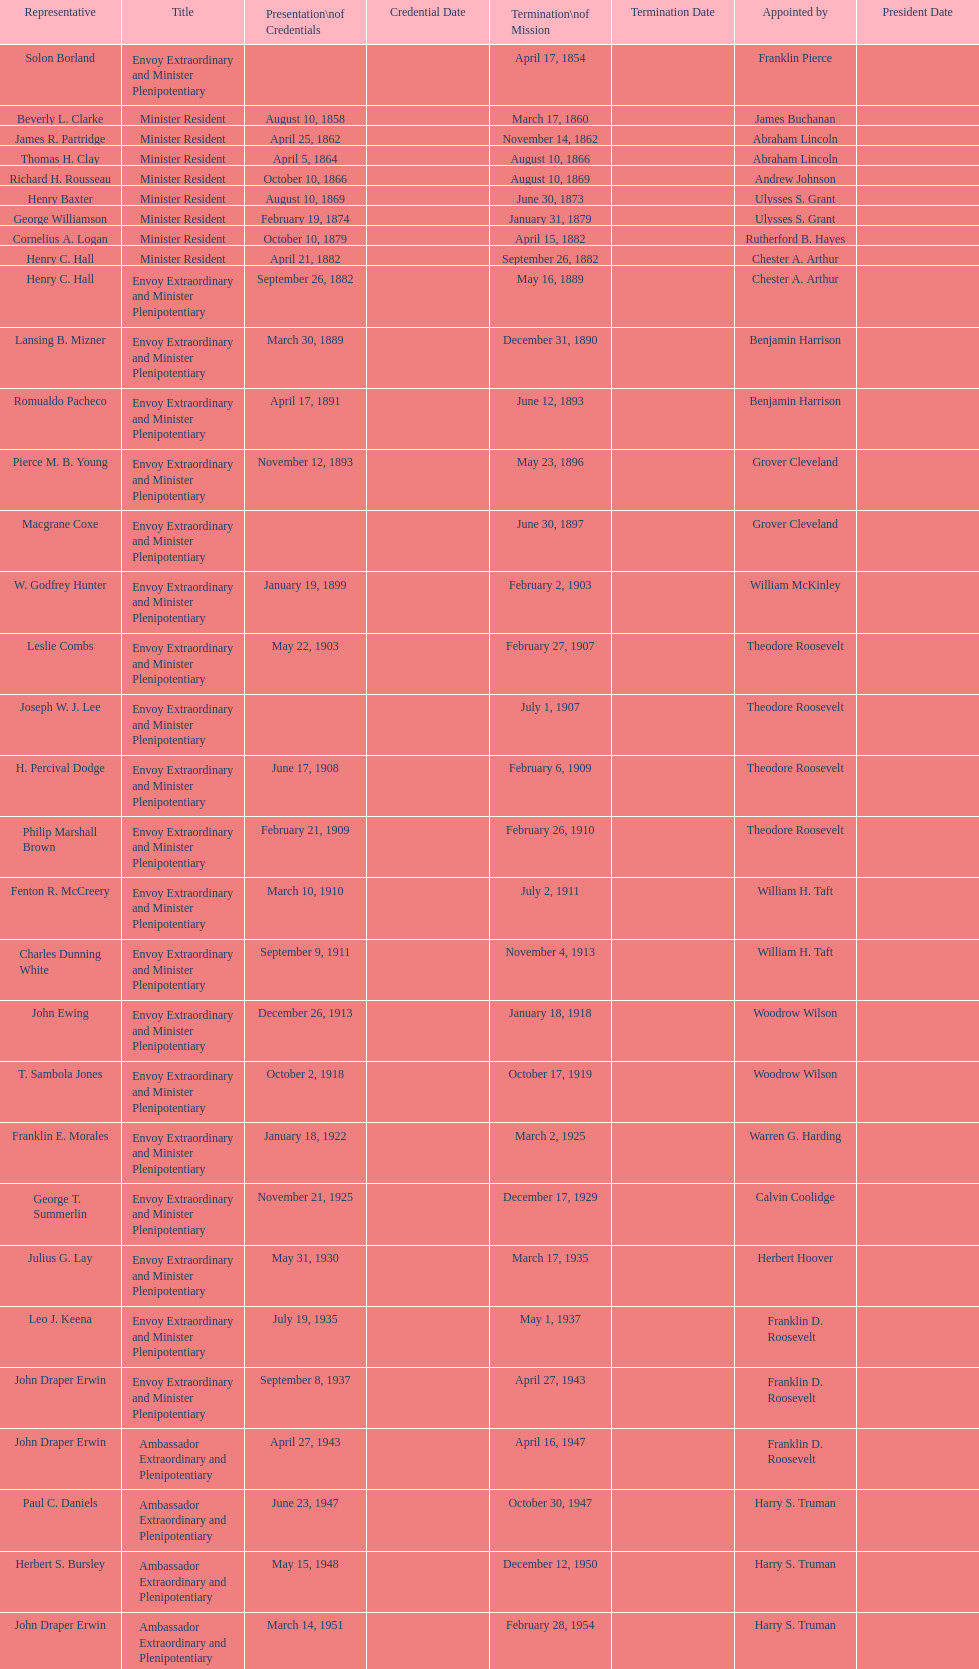Which envoy was the first appointed by woodrow wilson? John Ewing. 